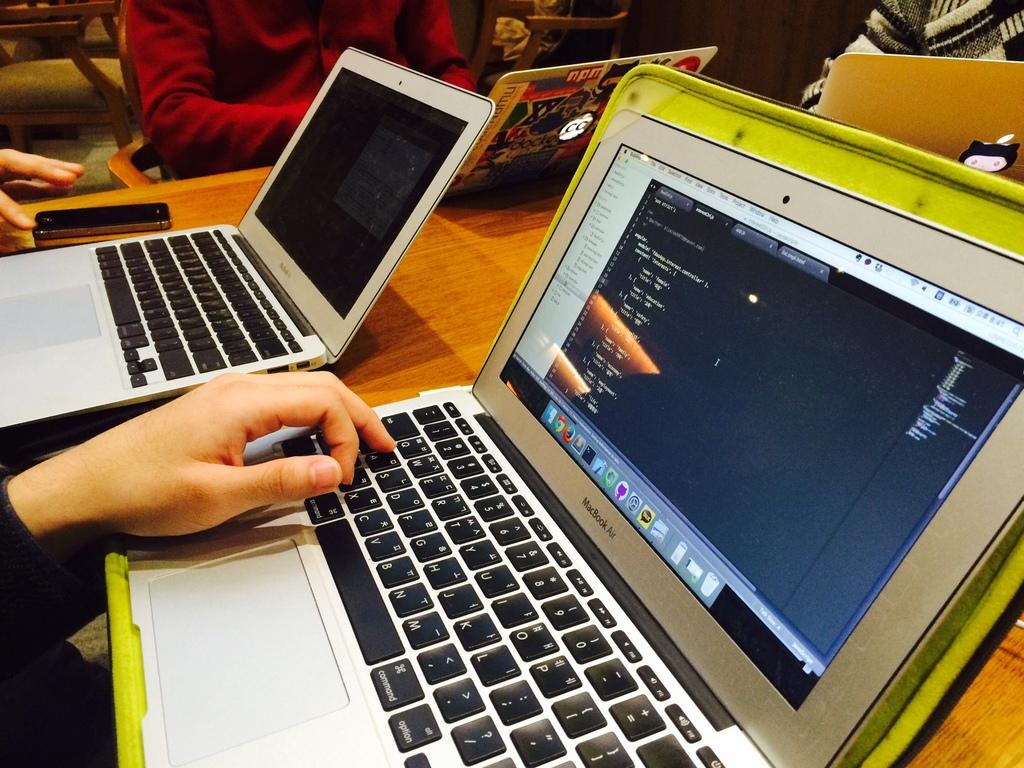What electronic devices can be seen in the image? There are laptops and a phone in the image. Where are the laptops and phone located? They are on a wooden table in the image. Are there any people present in the image? Yes, there are people visible in the image. What can be seen in the background of the image? A chair is present in the background of the image. What type of dock can be seen in the image? There is no dock present in the image. How many fans are visible in the image? There are no fans visible in the image. 